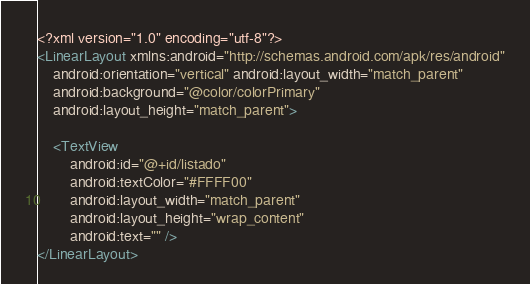Convert code to text. <code><loc_0><loc_0><loc_500><loc_500><_XML_><?xml version="1.0" encoding="utf-8"?>
<LinearLayout xmlns:android="http://schemas.android.com/apk/res/android"
    android:orientation="vertical" android:layout_width="match_parent"
    android:background="@color/colorPrimary"
    android:layout_height="match_parent">

    <TextView
        android:id="@+id/listado"
        android:textColor="#FFFF00"
        android:layout_width="match_parent"
        android:layout_height="wrap_content"
        android:text="" />
</LinearLayout></code> 